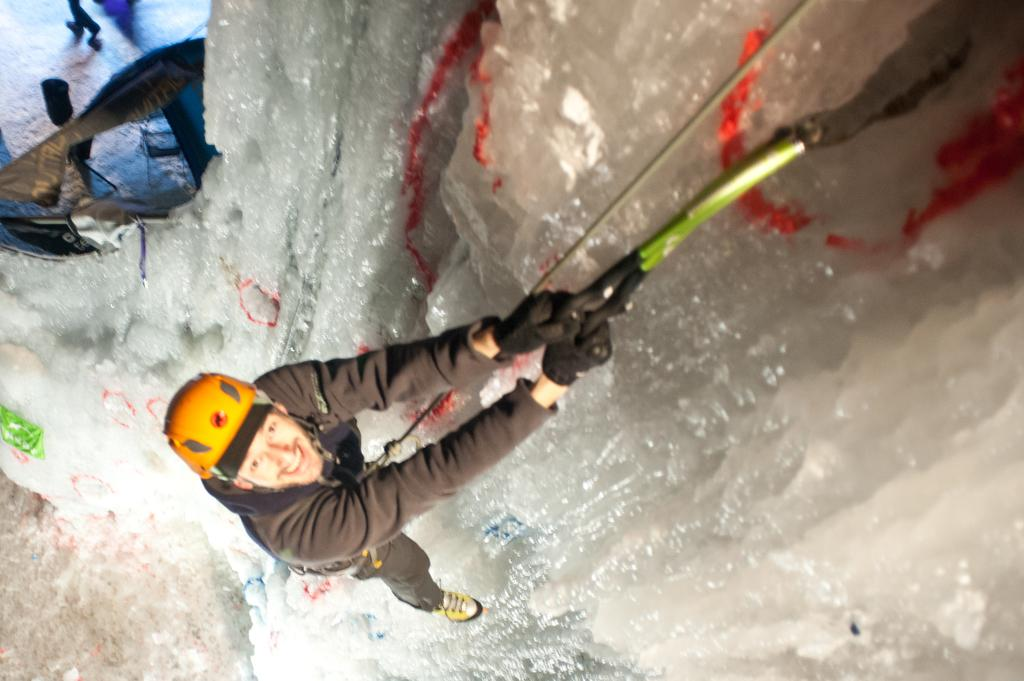What is the main subject of the image? There is a person in the image. What is the person doing in the image? The person is climbing a building. What is the person holding while climbing the building? The person is holding a rope. What colors can be seen in the person's clothing? The person is wearing a brown-colored dress and a yellow-colored cap. How many snails can be seen on the person's cap in the image? There are no snails present on the person's cap in the image. What type of pencil is the person using to draw on the building in the image? There is no pencil visible in the image, and the person is not drawing on the building. 